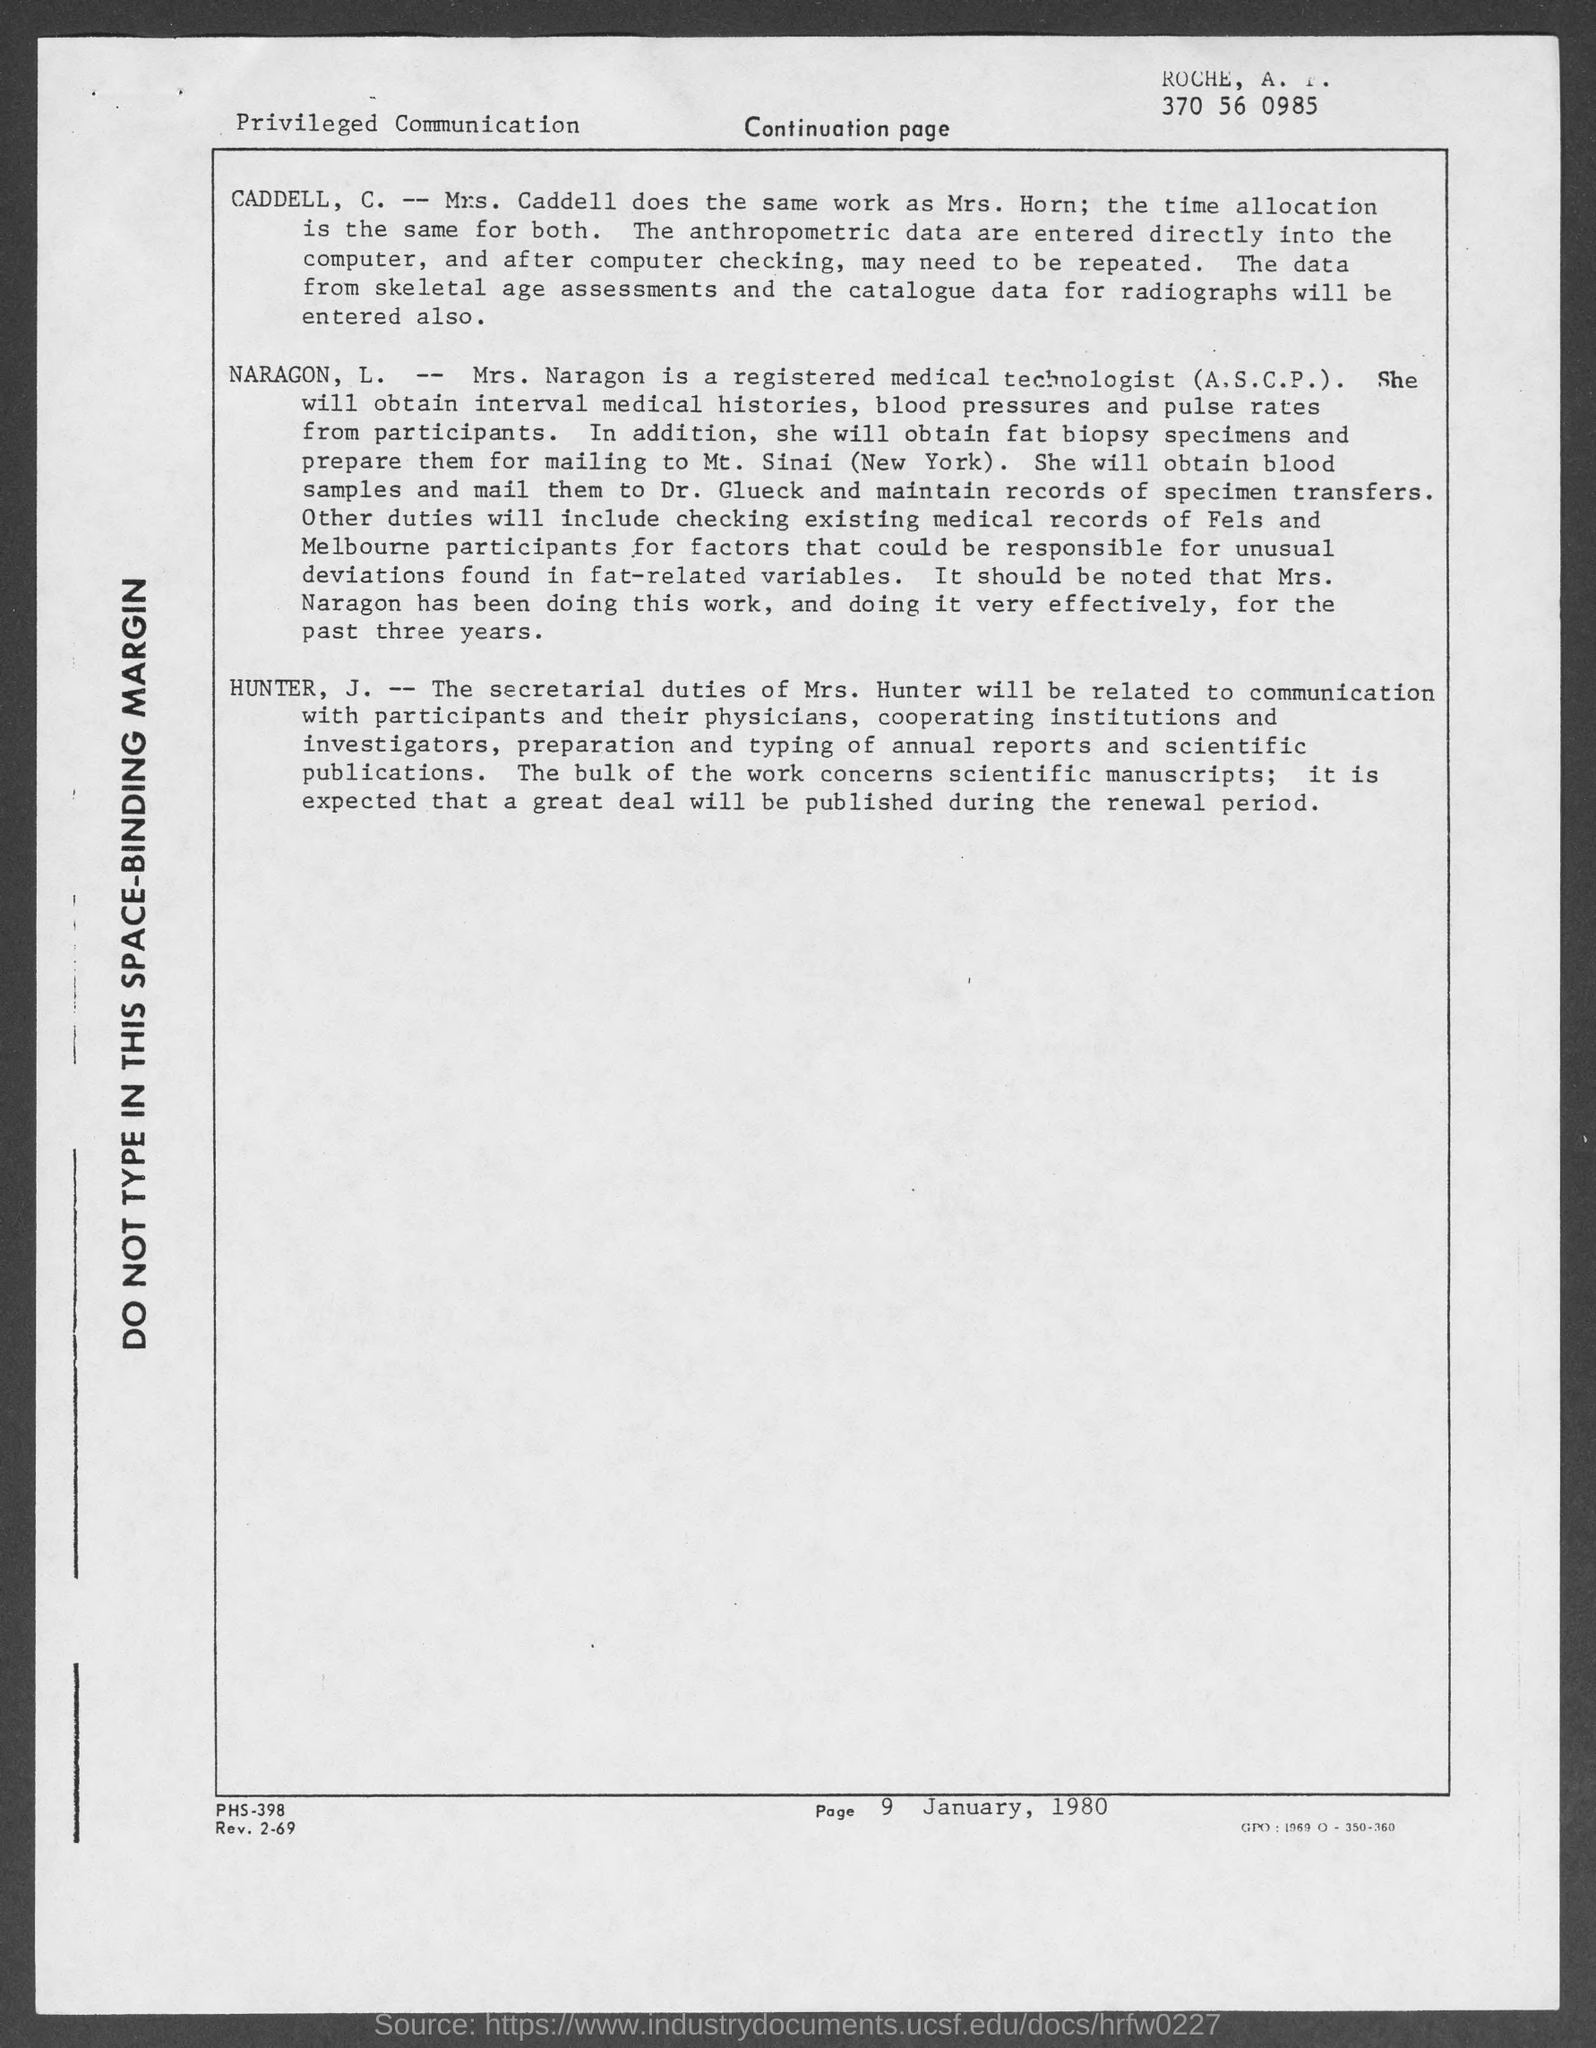Indicate a few pertinent items in this graphic. Mrs. Naragon, L., is a registered medical technologist (A.S.C.P.). 